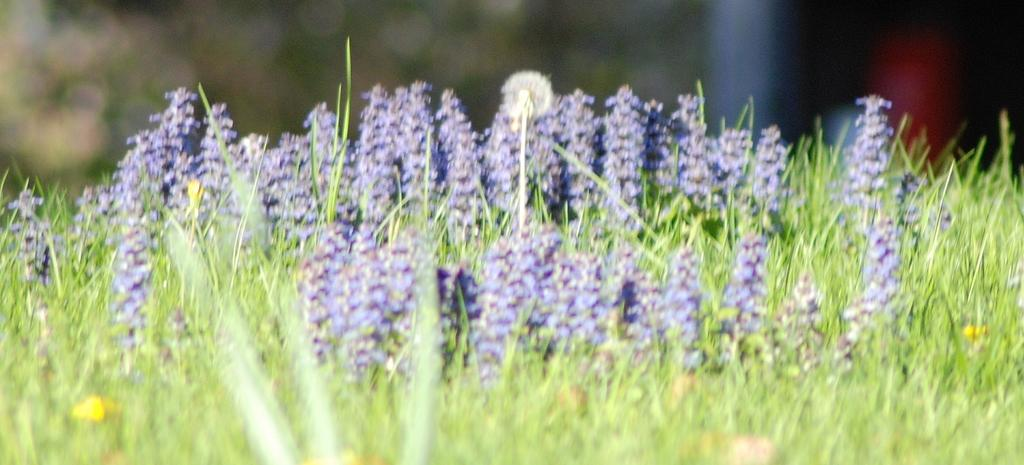What type of vegetation is visible in the front of the image? There is grass in the front of the image. What can be seen in the center of the image? There are flowers in the center of the image. How would you describe the background of the image? The background of the image is blurry. What type of glass is used to create the pie in the image? There is no pie present in the image, so it is not possible to determine what type of glass might be used. 